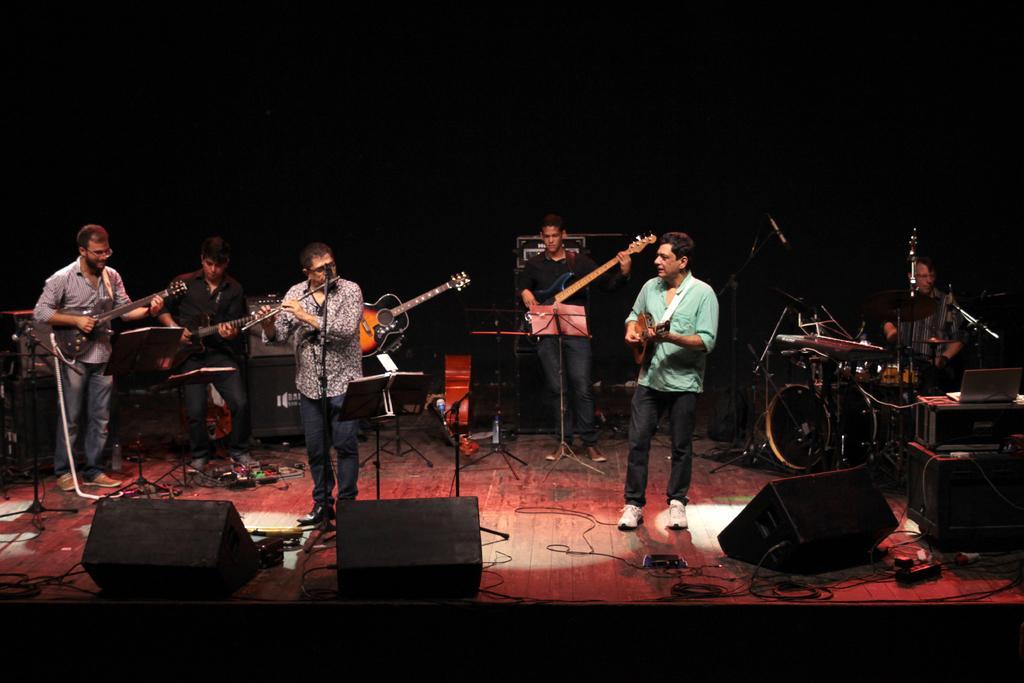Describe this image in one or two sentences. In this picture we can see some persons are standing on the stage and playing guitars. And these are some musical instruments. 